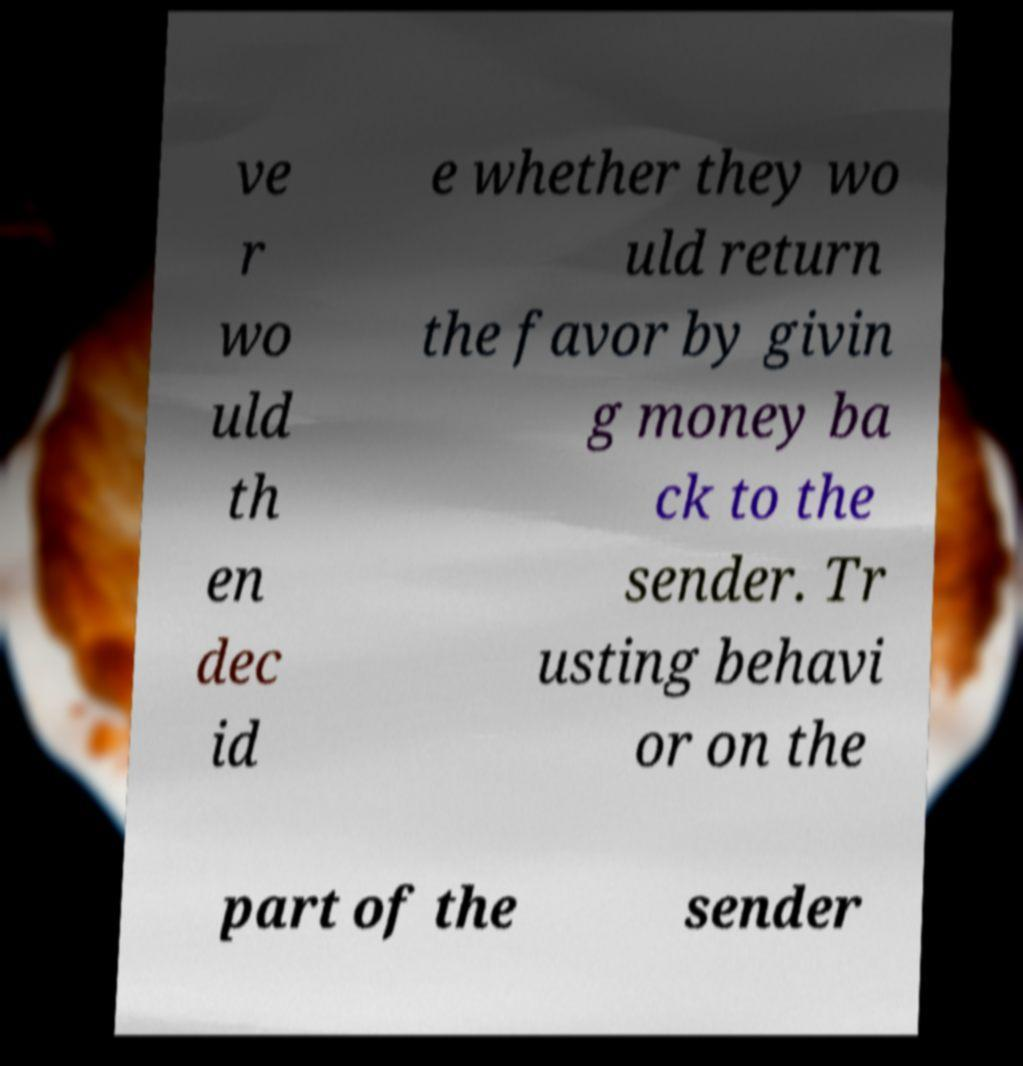Please read and relay the text visible in this image. What does it say? ve r wo uld th en dec id e whether they wo uld return the favor by givin g money ba ck to the sender. Tr usting behavi or on the part of the sender 